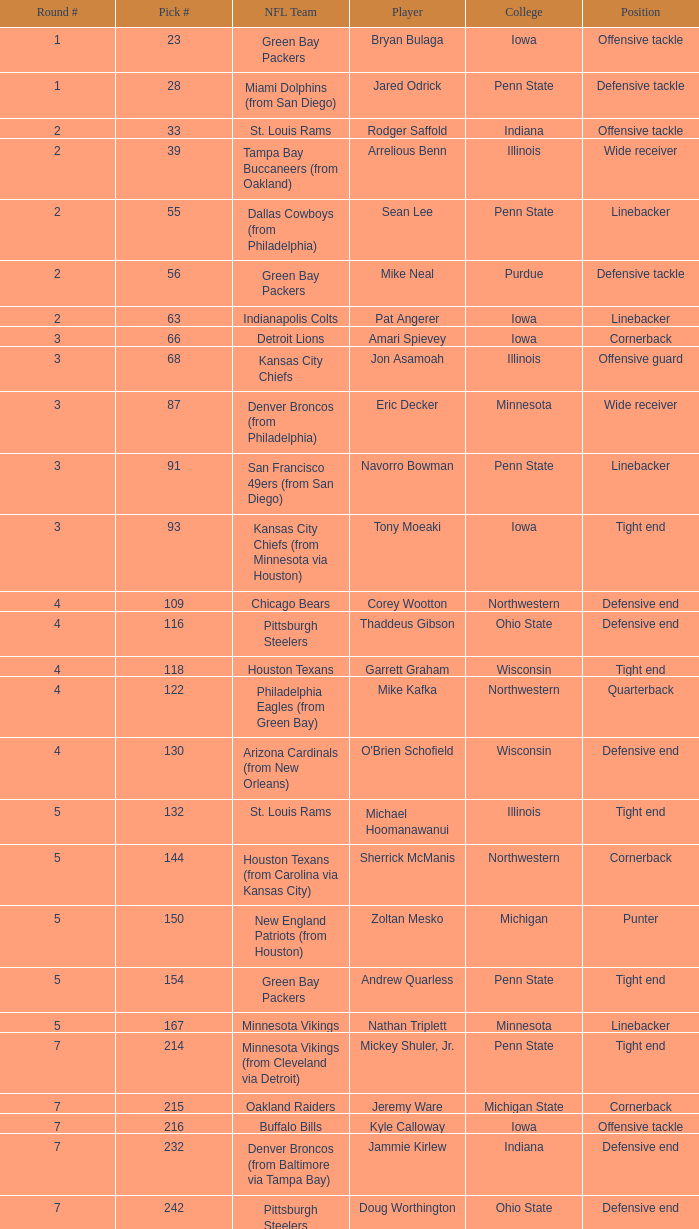What was Sherrick McManis's earliest round? 5.0. 